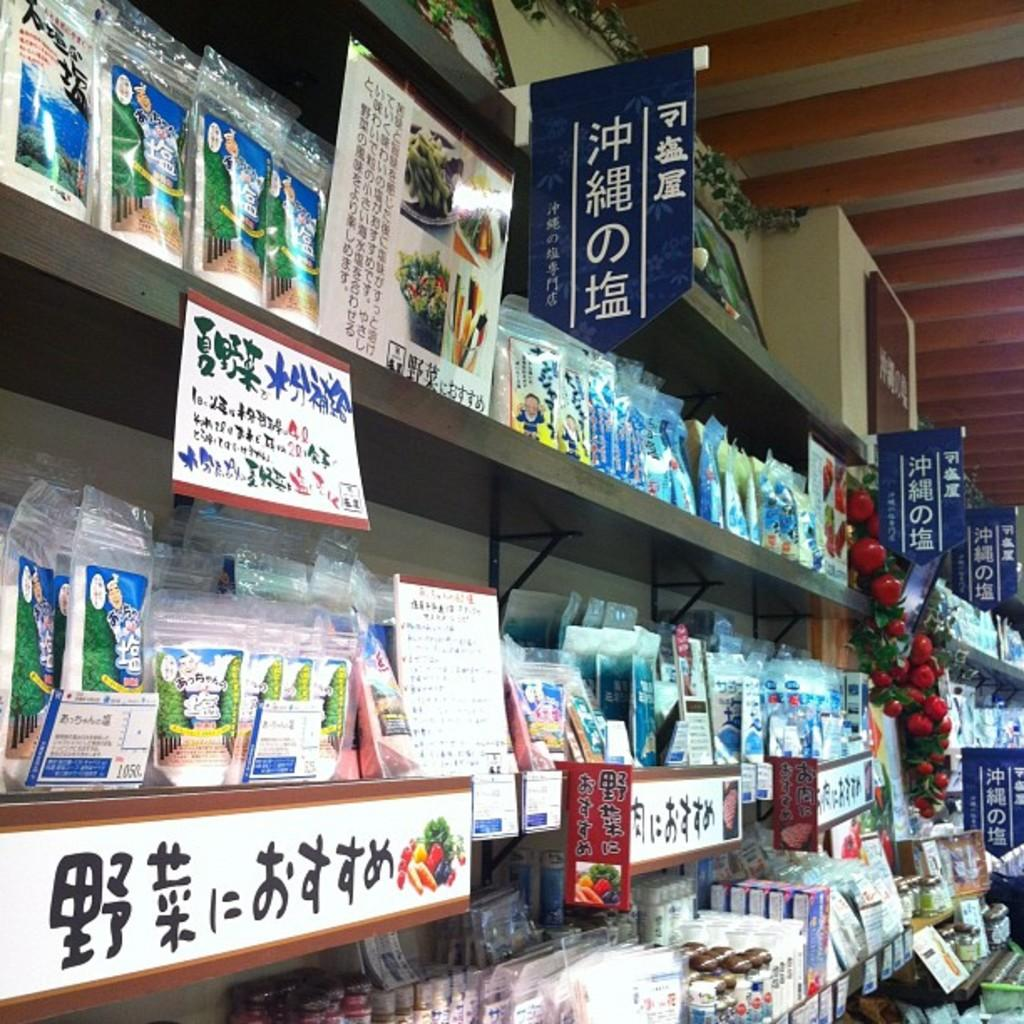Provide a one-sentence caption for the provided image. The second row of items, far left has a card with the numbers 1050 in the lower right corner. 